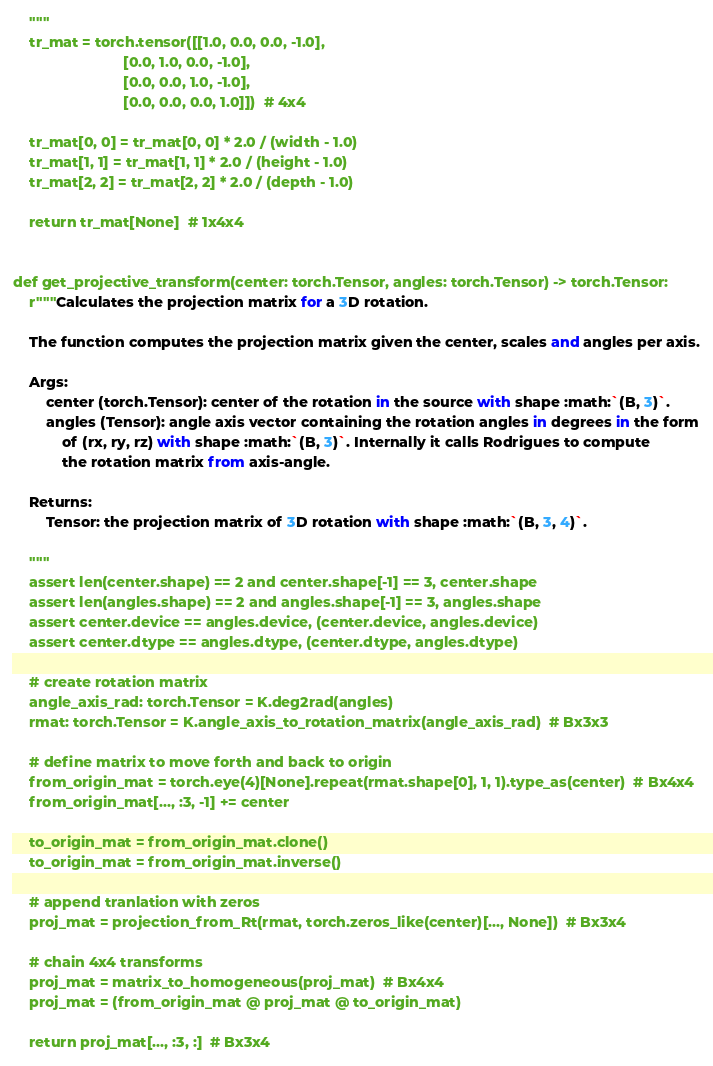<code> <loc_0><loc_0><loc_500><loc_500><_Python_>
    """
    tr_mat = torch.tensor([[1.0, 0.0, 0.0, -1.0],
                           [0.0, 1.0, 0.0, -1.0],
                           [0.0, 0.0, 1.0, -1.0],
                           [0.0, 0.0, 0.0, 1.0]])  # 4x4

    tr_mat[0, 0] = tr_mat[0, 0] * 2.0 / (width - 1.0)
    tr_mat[1, 1] = tr_mat[1, 1] * 2.0 / (height - 1.0)
    tr_mat[2, 2] = tr_mat[2, 2] * 2.0 / (depth - 1.0)

    return tr_mat[None]  # 1x4x4


def get_projective_transform(center: torch.Tensor, angles: torch.Tensor) -> torch.Tensor:
    r"""Calculates the projection matrix for a 3D rotation.

    The function computes the projection matrix given the center, scales and angles per axis.

    Args:
        center (torch.Tensor): center of the rotation in the source with shape :math:`(B, 3)`.
        angles (Tensor): angle axis vector containing the rotation angles in degrees in the form
            of (rx, ry, rz) with shape :math:`(B, 3)`. Internally it calls Rodrigues to compute
            the rotation matrix from axis-angle.

    Returns:
        Tensor: the projection matrix of 3D rotation with shape :math:`(B, 3, 4)`.

    """
    assert len(center.shape) == 2 and center.shape[-1] == 3, center.shape
    assert len(angles.shape) == 2 and angles.shape[-1] == 3, angles.shape
    assert center.device == angles.device, (center.device, angles.device)
    assert center.dtype == angles.dtype, (center.dtype, angles.dtype)

    # create rotation matrix
    angle_axis_rad: torch.Tensor = K.deg2rad(angles)
    rmat: torch.Tensor = K.angle_axis_to_rotation_matrix(angle_axis_rad)  # Bx3x3

    # define matrix to move forth and back to origin
    from_origin_mat = torch.eye(4)[None].repeat(rmat.shape[0], 1, 1).type_as(center)  # Bx4x4
    from_origin_mat[..., :3, -1] += center

    to_origin_mat = from_origin_mat.clone()
    to_origin_mat = from_origin_mat.inverse()

    # append tranlation with zeros
    proj_mat = projection_from_Rt(rmat, torch.zeros_like(center)[..., None])  # Bx3x4

    # chain 4x4 transforms
    proj_mat = matrix_to_homogeneous(proj_mat)  # Bx4x4
    proj_mat = (from_origin_mat @ proj_mat @ to_origin_mat)

    return proj_mat[..., :3, :]  # Bx3x4
</code> 